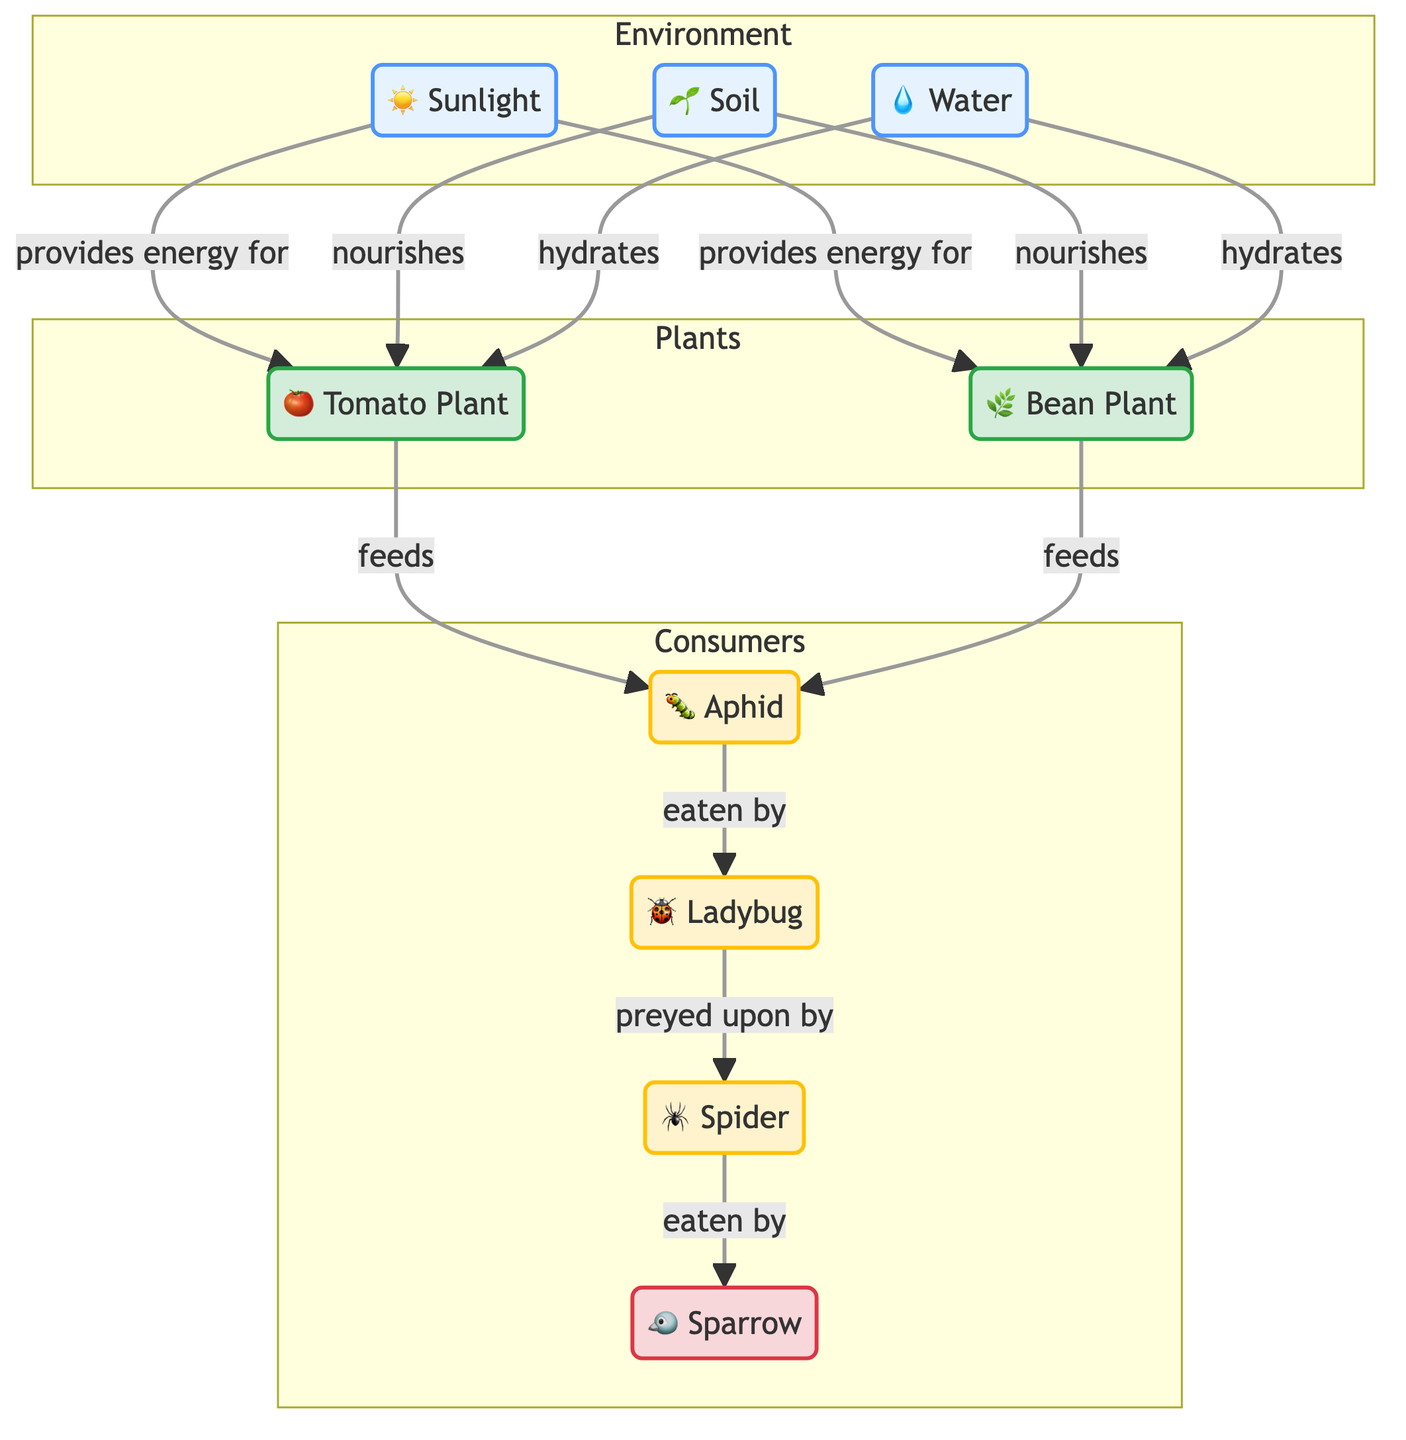What are the main abiotic components in the ecosystem? The diagram lists three main abiotic components: Sunlight, Soil, and Water. Each component is linked to the plants, showing their significance in the ecosystem.
Answer: Sunlight, Soil, Water Which organisms feed on aphids in the ecosystem? The diagram indicates that ladybugs feed on aphids, connecting the two nodes with the relationship labeled "eaten by."
Answer: Ladybug How many different types of plants are represented in the diagram? There are two types of plants shown: Tomato Plant and Bean Plant. This count is based on the distinct plant nodes in the diagram.
Answer: 2 What type of relationship exists between ladybugs and spiders? The relationship shown in the diagram is that ladybugs are preyed upon by spiders, demonstrated by the labeled arrow connecting these two nodes.
Answer: Preyed upon Which organism is at the top of the food chain in this backyard garden ecosystem? Following the flow of the diagram, sparrows are the apex consumers, as they are not eaten by any other organisms, making them the top of the food chain.
Answer: Sparrow What is the role of sunlight in the ecosystem? Sunlight is described in the diagram as providing energy for both the tomato and bean plants, linking it to both plants and showcasing its importance for growth.
Answer: Provides energy Which insect is a primary food source for aphids? The diagram indicates that both the tomato and bean plants feed aphids, establishing a direct relationship where aphids gain nourishment from these plants.
Answer: Tomato Plant, Bean Plant What connection exists between spiders and sparrows? The diagram illustrates that spiders are eaten by sparrows, indicating a predator-prey relationship between these two organisms.
Answer: Eaten by 